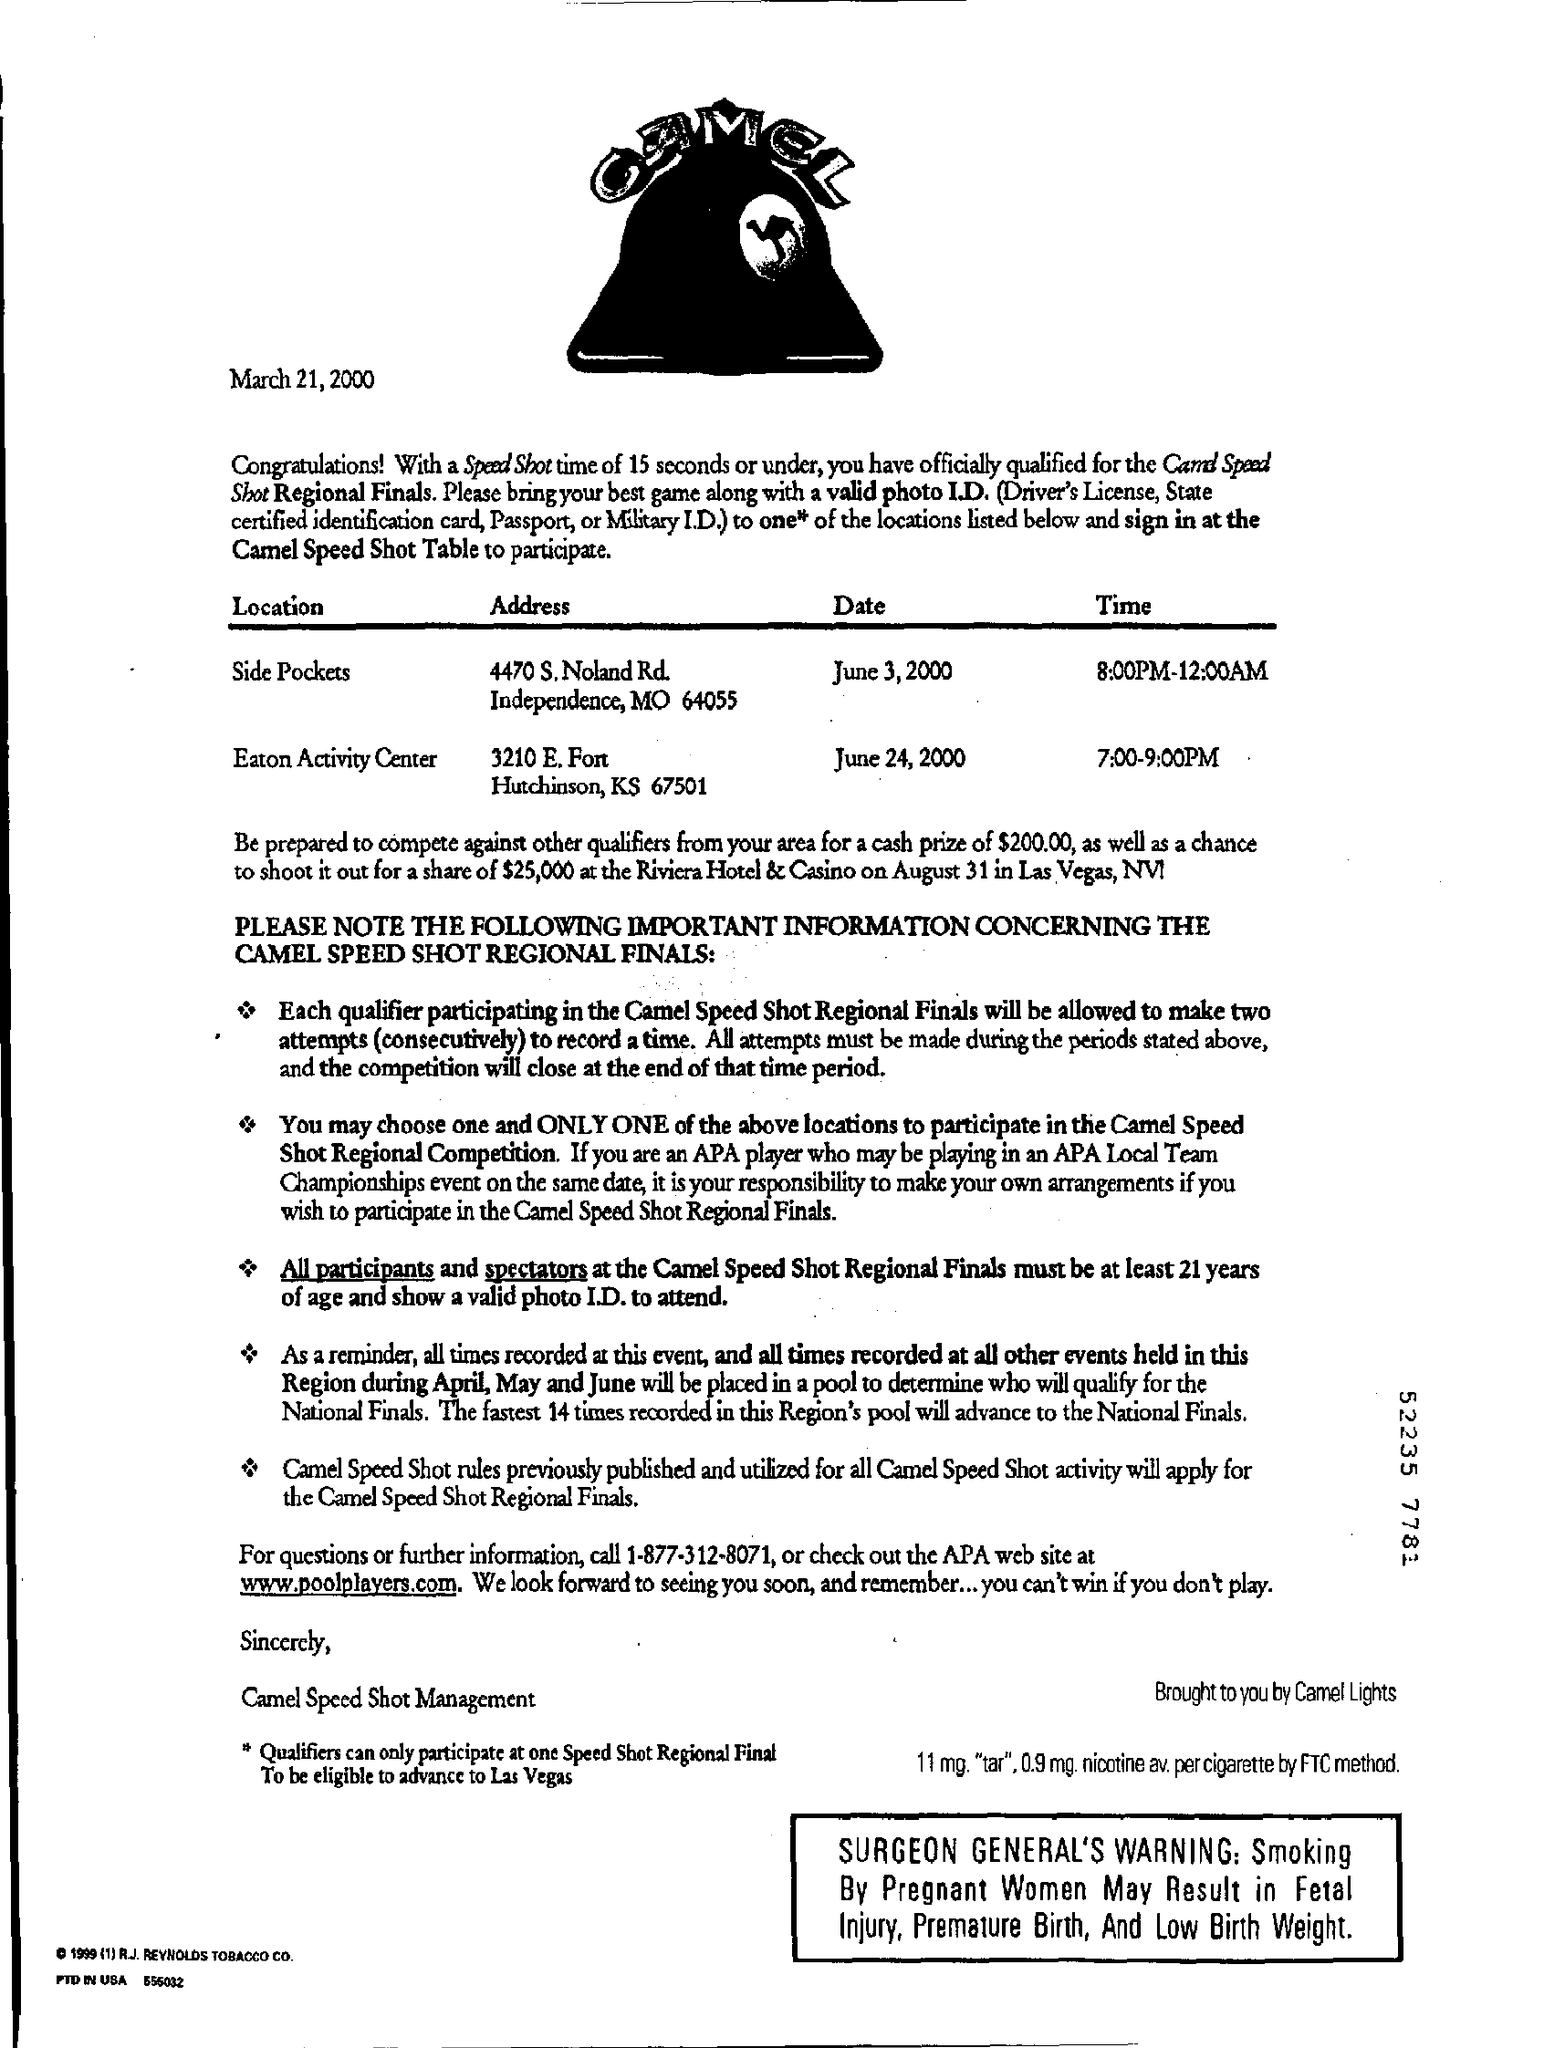Where is the location of finals on June 3, 2000?
Give a very brief answer. Side Pockets. What is the cash price of qualifiers from your area?
Ensure brevity in your answer.  $200.00. Whats the web site mentioned for quarries and further information?
Ensure brevity in your answer.  Www.poolplayers.com. 